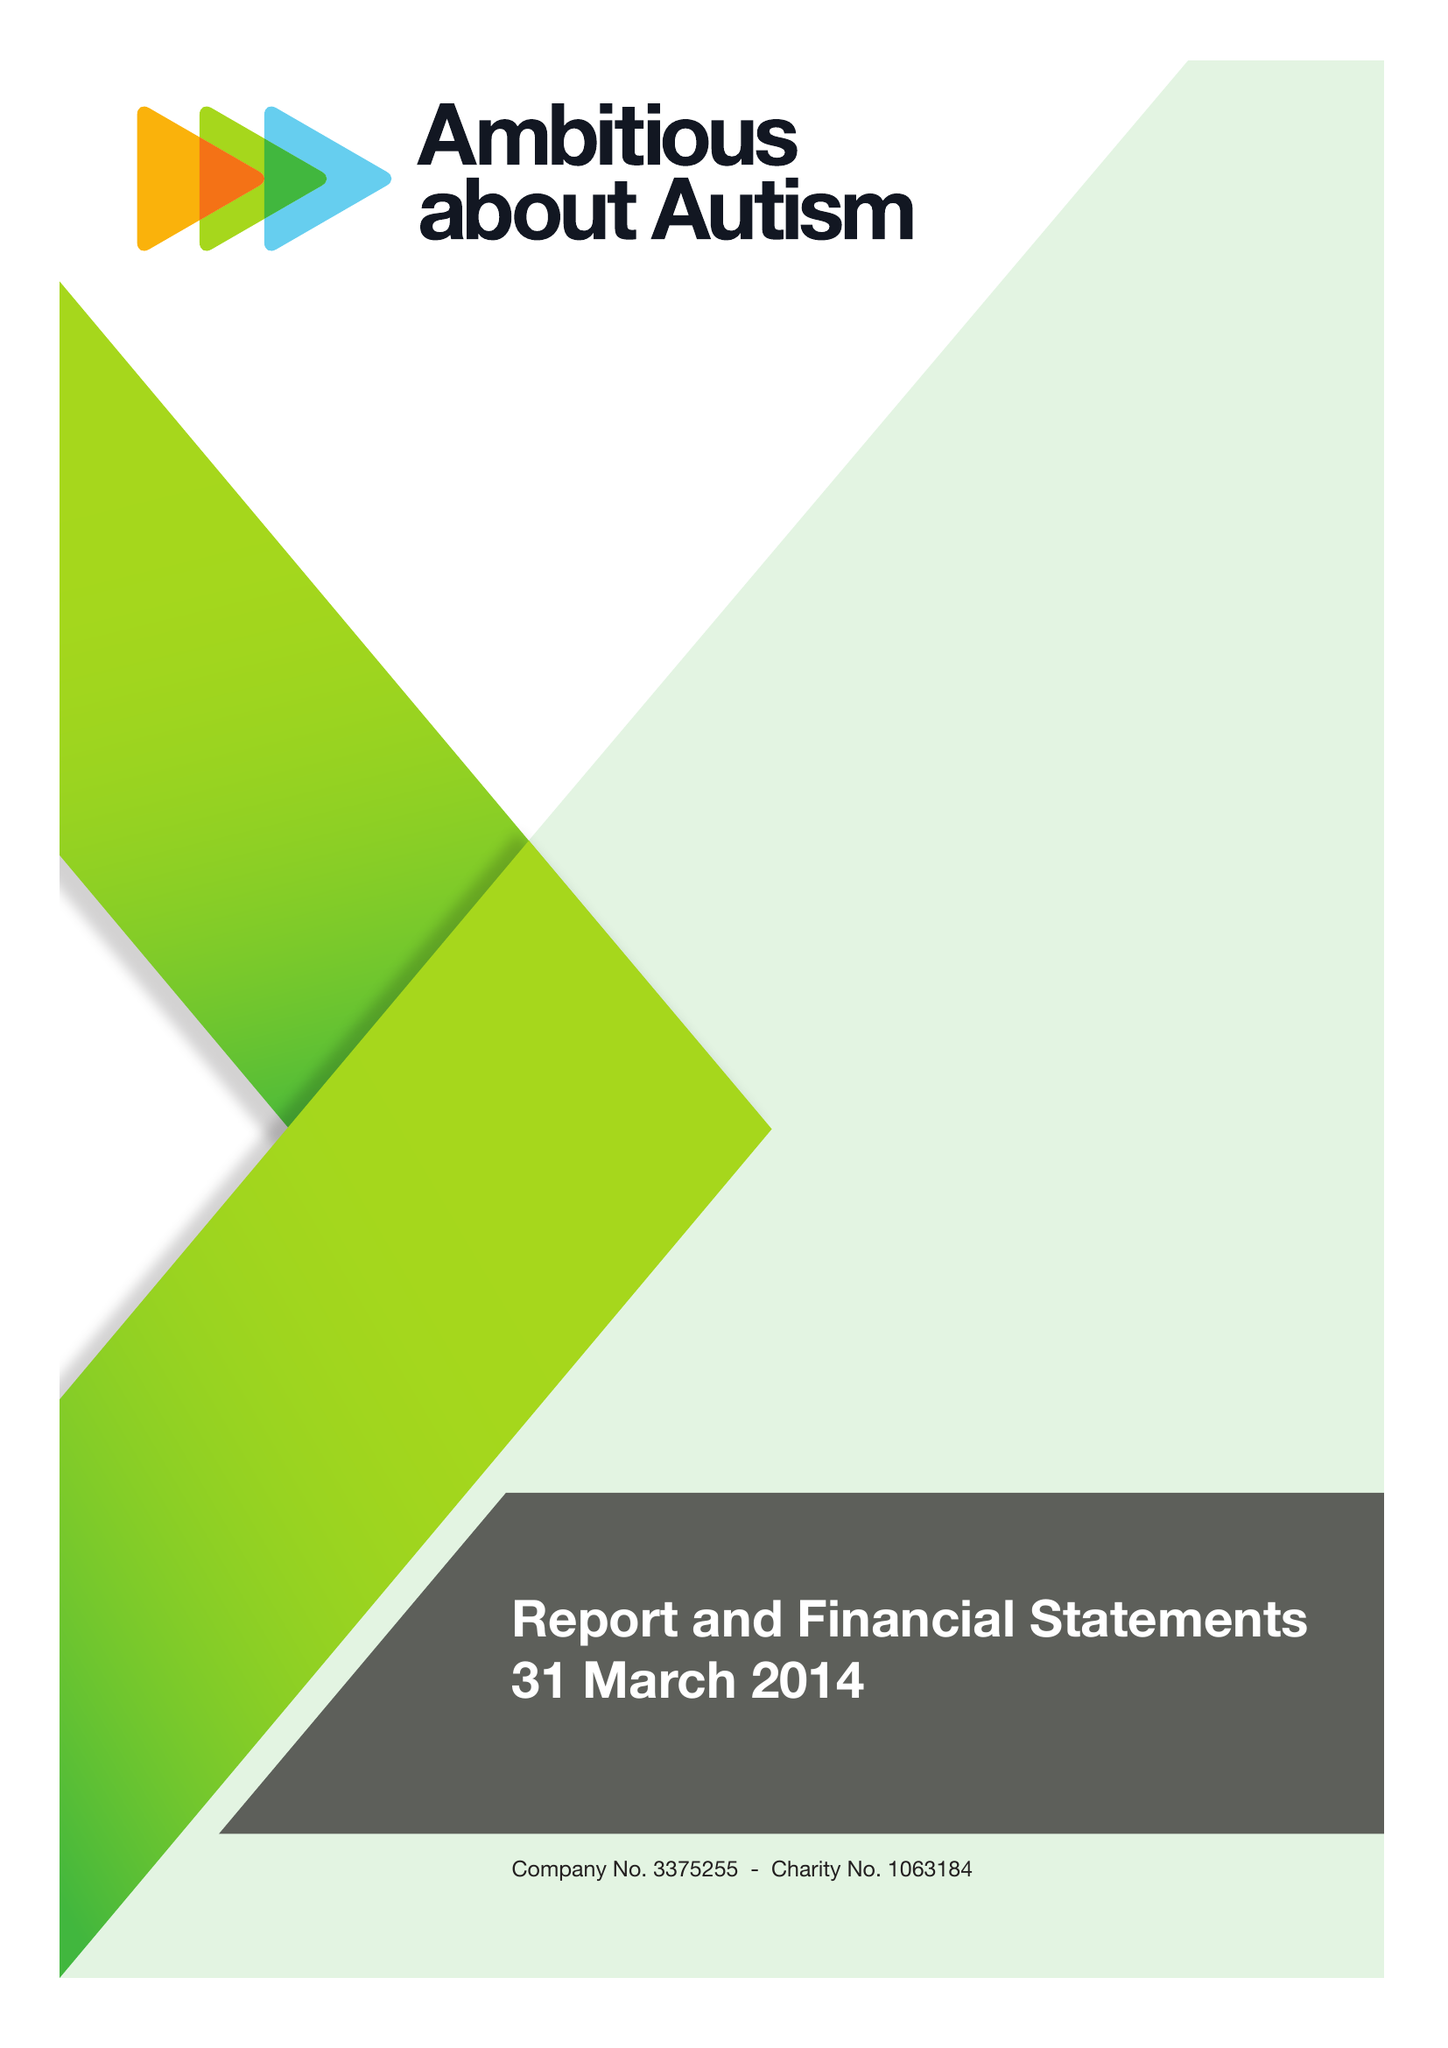What is the value for the charity_name?
Answer the question using a single word or phrase. Ambitious About Autism 